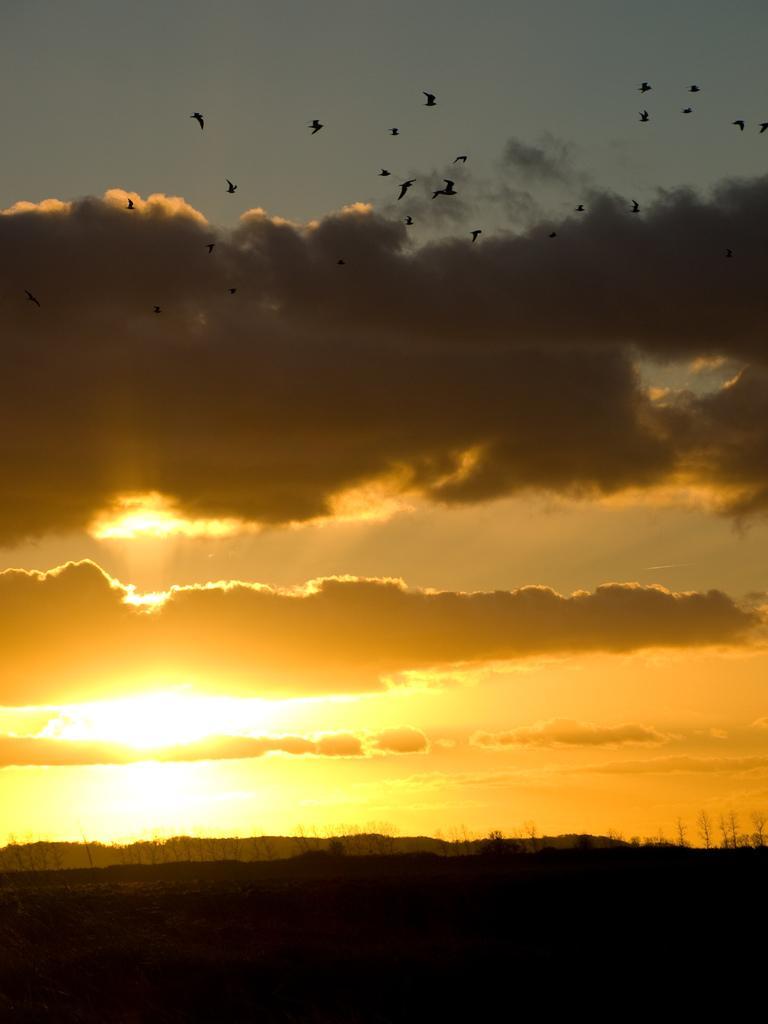Could you give a brief overview of what you see in this image? In this picture we can see trees and we can see sky,birds flying in the background. 